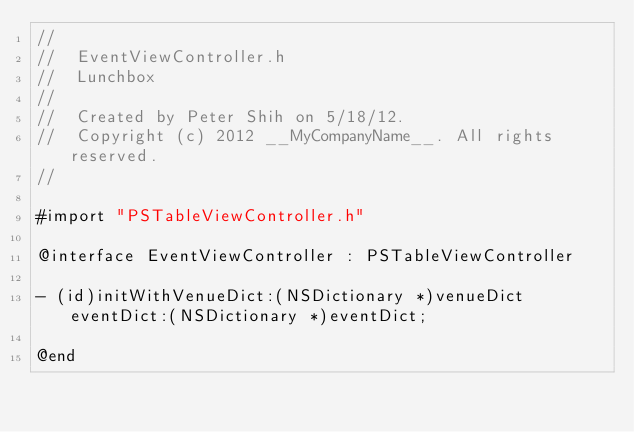Convert code to text. <code><loc_0><loc_0><loc_500><loc_500><_C_>//
//  EventViewController.h
//  Lunchbox
//
//  Created by Peter Shih on 5/18/12.
//  Copyright (c) 2012 __MyCompanyName__. All rights reserved.
//

#import "PSTableViewController.h"

@interface EventViewController : PSTableViewController

- (id)initWithVenueDict:(NSDictionary *)venueDict eventDict:(NSDictionary *)eventDict;

@end
</code> 